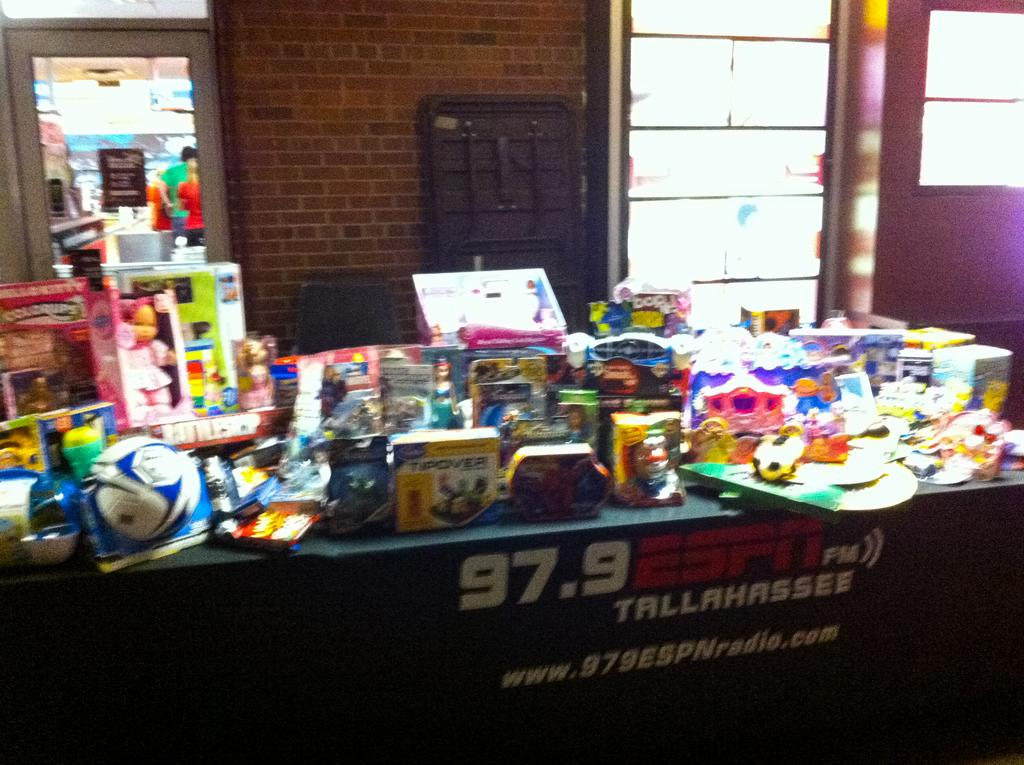<image>
Render a clear and concise summary of the photo. A table for 97.9 ESPN Tallahassee has many different items on it such as a soccer ball and other toys. 